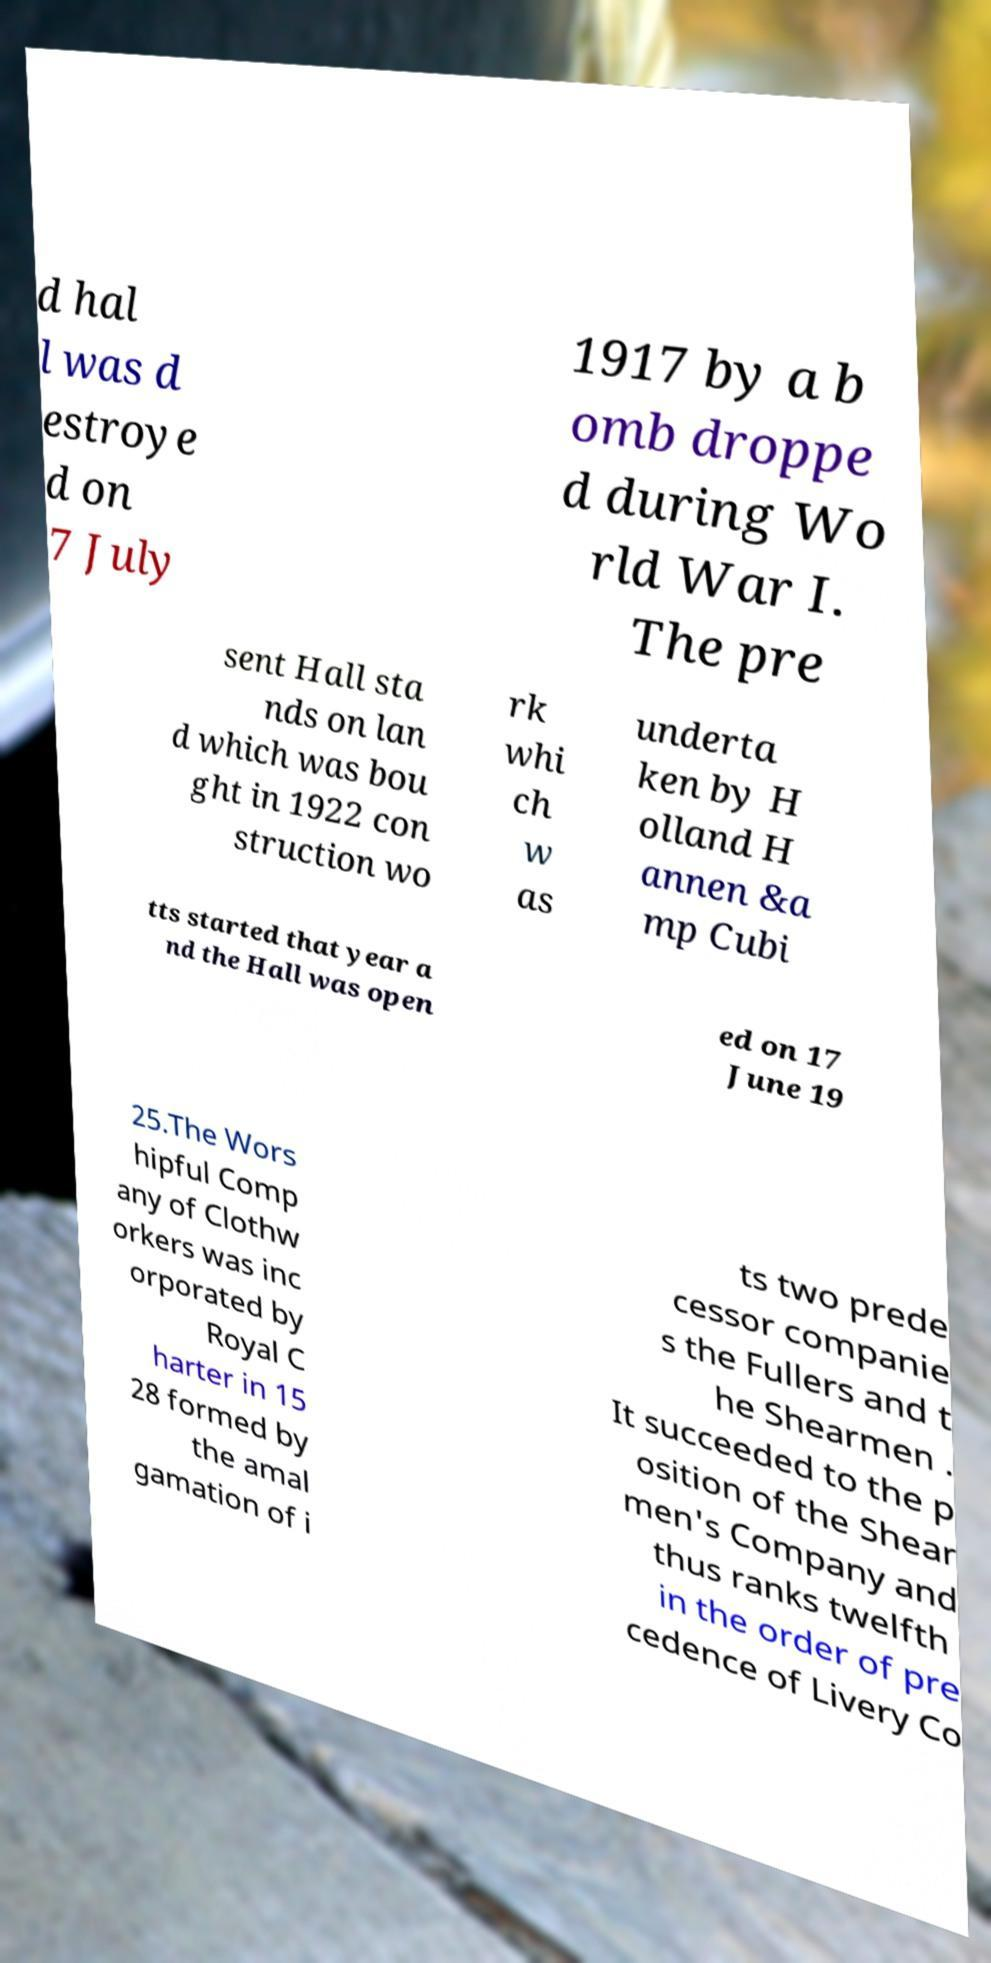What messages or text are displayed in this image? I need them in a readable, typed format. d hal l was d estroye d on 7 July 1917 by a b omb droppe d during Wo rld War I. The pre sent Hall sta nds on lan d which was bou ght in 1922 con struction wo rk whi ch w as underta ken by H olland H annen &a mp Cubi tts started that year a nd the Hall was open ed on 17 June 19 25.The Wors hipful Comp any of Clothw orkers was inc orporated by Royal C harter in 15 28 formed by the amal gamation of i ts two prede cessor companie s the Fullers and t he Shearmen . It succeeded to the p osition of the Shear men's Company and thus ranks twelfth in the order of pre cedence of Livery Co 